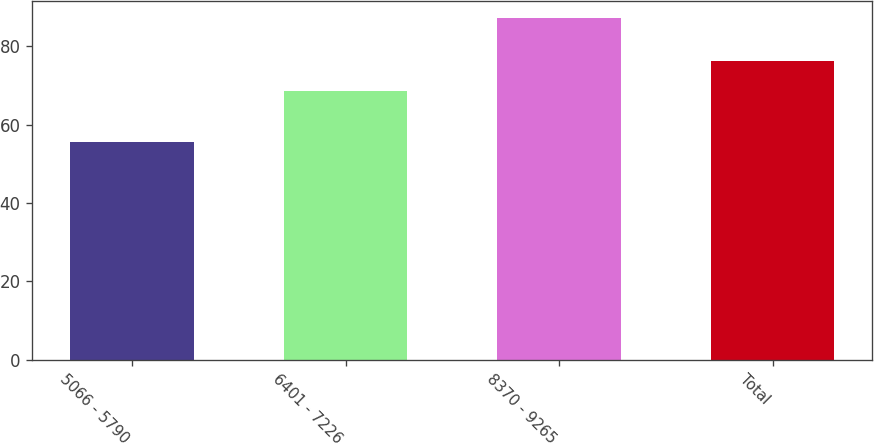<chart> <loc_0><loc_0><loc_500><loc_500><bar_chart><fcel>5066 - 5790<fcel>6401 - 7226<fcel>8370 - 9265<fcel>Total<nl><fcel>55.47<fcel>68.59<fcel>87.21<fcel>76.31<nl></chart> 